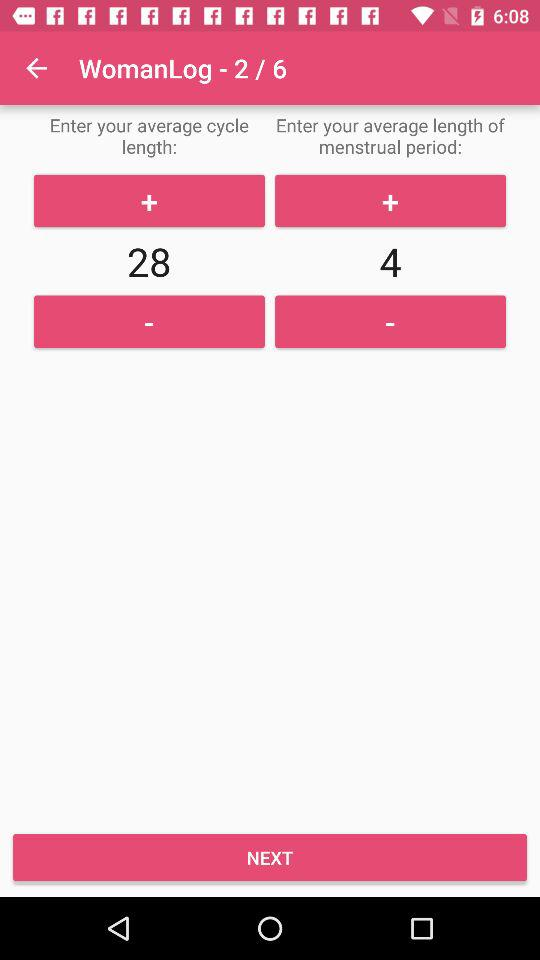How many days long is the average menstrual period?
Answer the question using a single word or phrase. 4 